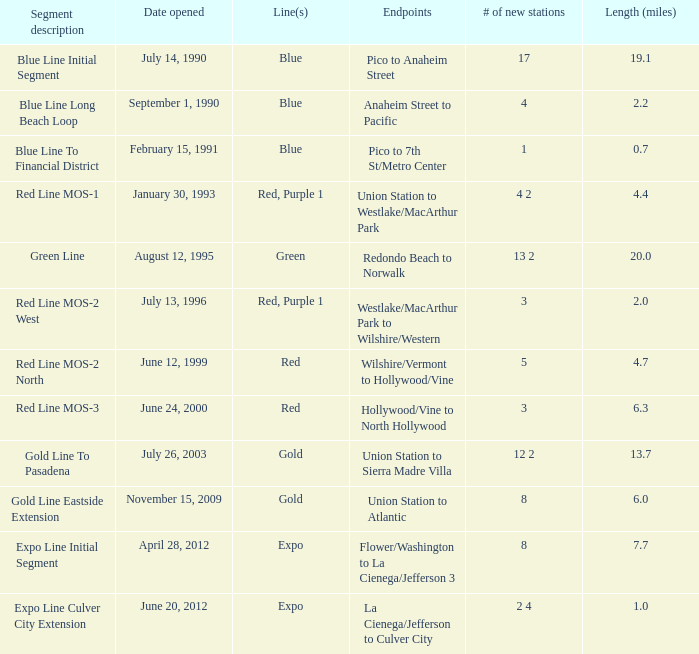What is the distance (miles) when pico and 7th st/metro center are the endpoints? 0.7. 